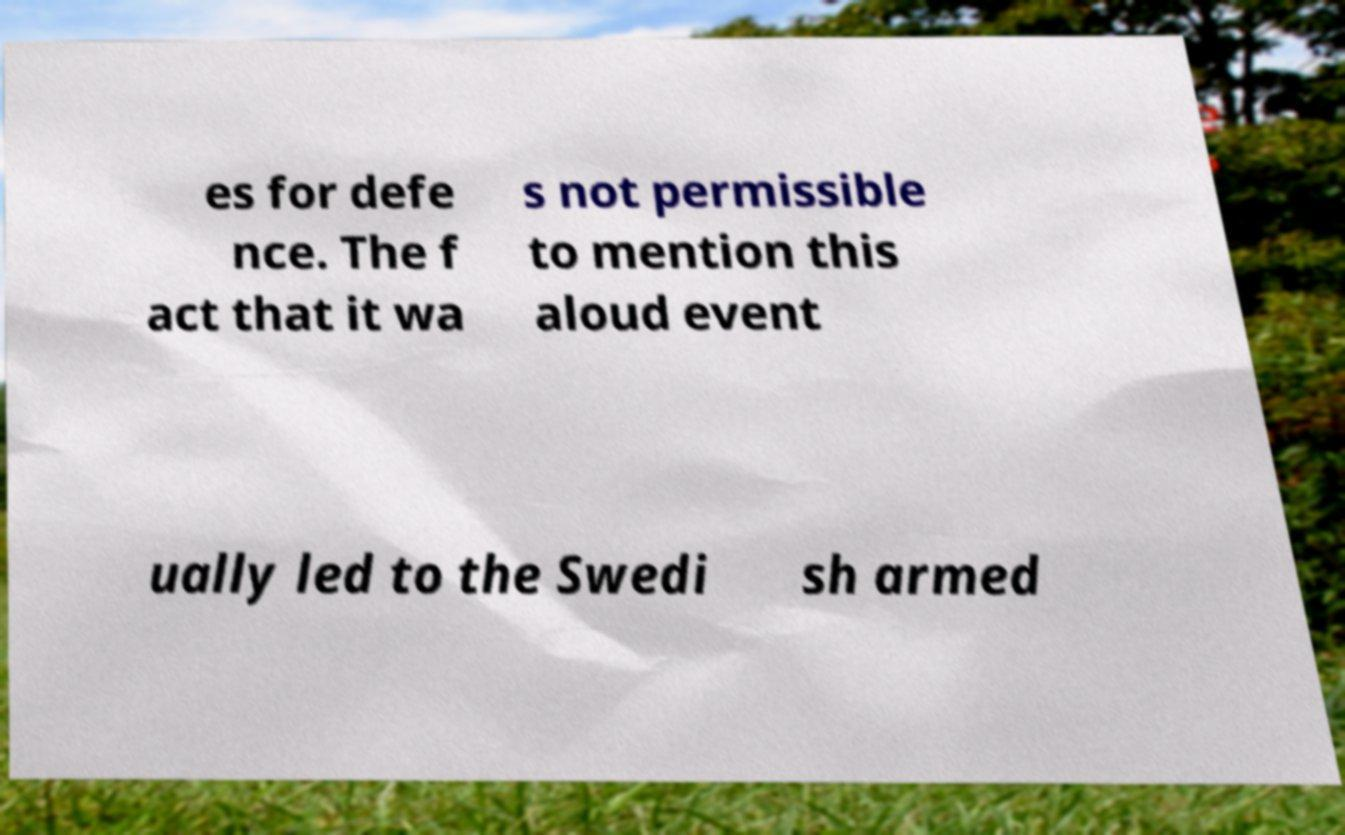Please identify and transcribe the text found in this image. es for defe nce. The f act that it wa s not permissible to mention this aloud event ually led to the Swedi sh armed 